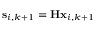<formula> <loc_0><loc_0><loc_500><loc_500>s _ { i , k + 1 } = H x _ { i , k + 1 }</formula> 